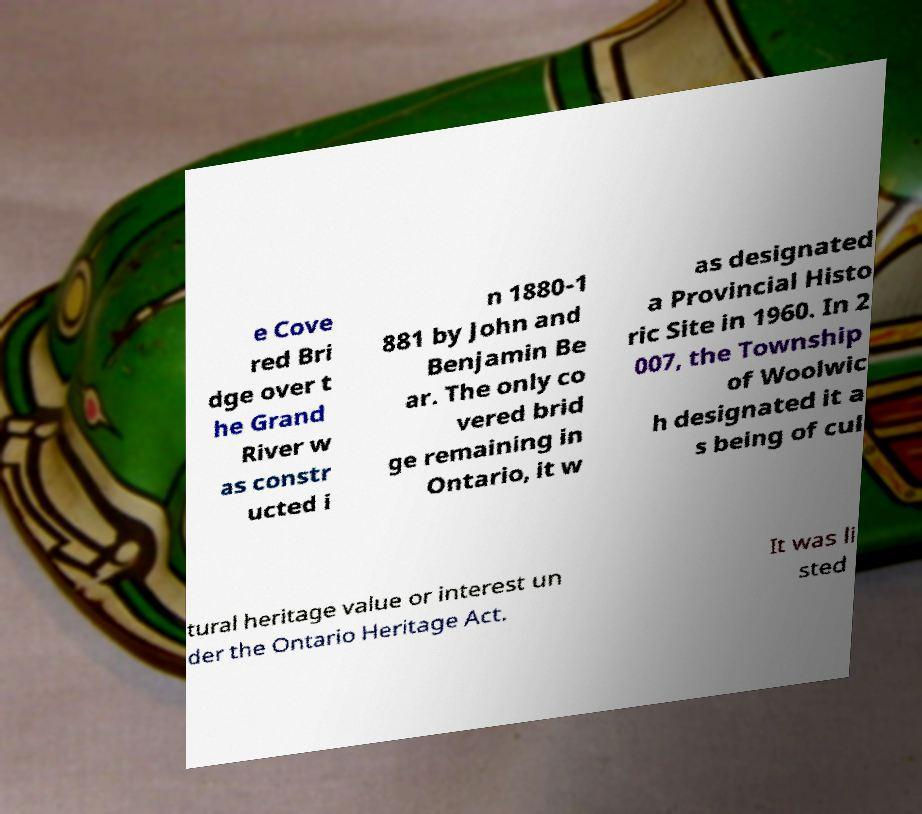Please identify and transcribe the text found in this image. e Cove red Bri dge over t he Grand River w as constr ucted i n 1880-1 881 by John and Benjamin Be ar. The only co vered brid ge remaining in Ontario, it w as designated a Provincial Histo ric Site in 1960. In 2 007, the Township of Woolwic h designated it a s being of cul tural heritage value or interest un der the Ontario Heritage Act. It was li sted 